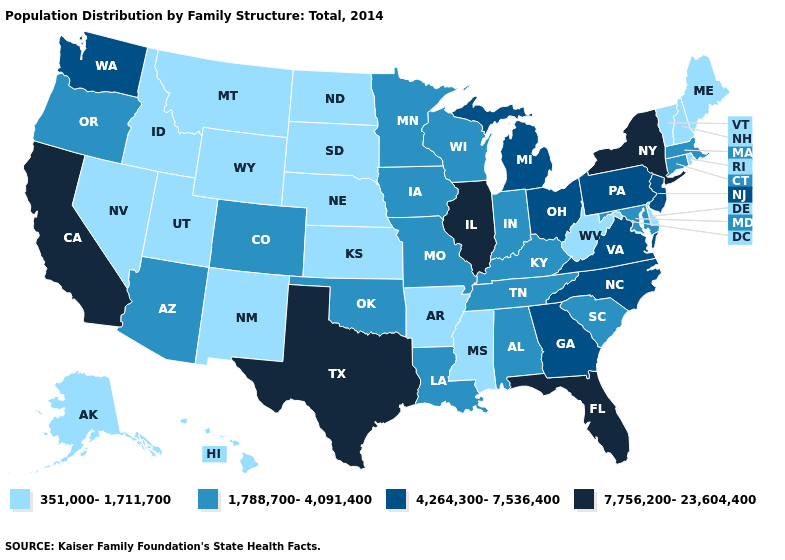Name the states that have a value in the range 351,000-1,711,700?
Answer briefly. Alaska, Arkansas, Delaware, Hawaii, Idaho, Kansas, Maine, Mississippi, Montana, Nebraska, Nevada, New Hampshire, New Mexico, North Dakota, Rhode Island, South Dakota, Utah, Vermont, West Virginia, Wyoming. Does Connecticut have the highest value in the Northeast?
Give a very brief answer. No. What is the lowest value in the South?
Give a very brief answer. 351,000-1,711,700. What is the lowest value in the USA?
Short answer required. 351,000-1,711,700. Among the states that border Washington , which have the lowest value?
Short answer required. Idaho. How many symbols are there in the legend?
Concise answer only. 4. Which states have the lowest value in the USA?
Short answer required. Alaska, Arkansas, Delaware, Hawaii, Idaho, Kansas, Maine, Mississippi, Montana, Nebraska, Nevada, New Hampshire, New Mexico, North Dakota, Rhode Island, South Dakota, Utah, Vermont, West Virginia, Wyoming. What is the highest value in the MidWest ?
Write a very short answer. 7,756,200-23,604,400. What is the highest value in the USA?
Keep it brief. 7,756,200-23,604,400. What is the value of Connecticut?
Give a very brief answer. 1,788,700-4,091,400. Which states have the lowest value in the West?
Keep it brief. Alaska, Hawaii, Idaho, Montana, Nevada, New Mexico, Utah, Wyoming. Is the legend a continuous bar?
Answer briefly. No. What is the value of South Dakota?
Be succinct. 351,000-1,711,700. Which states have the lowest value in the South?
Give a very brief answer. Arkansas, Delaware, Mississippi, West Virginia. 